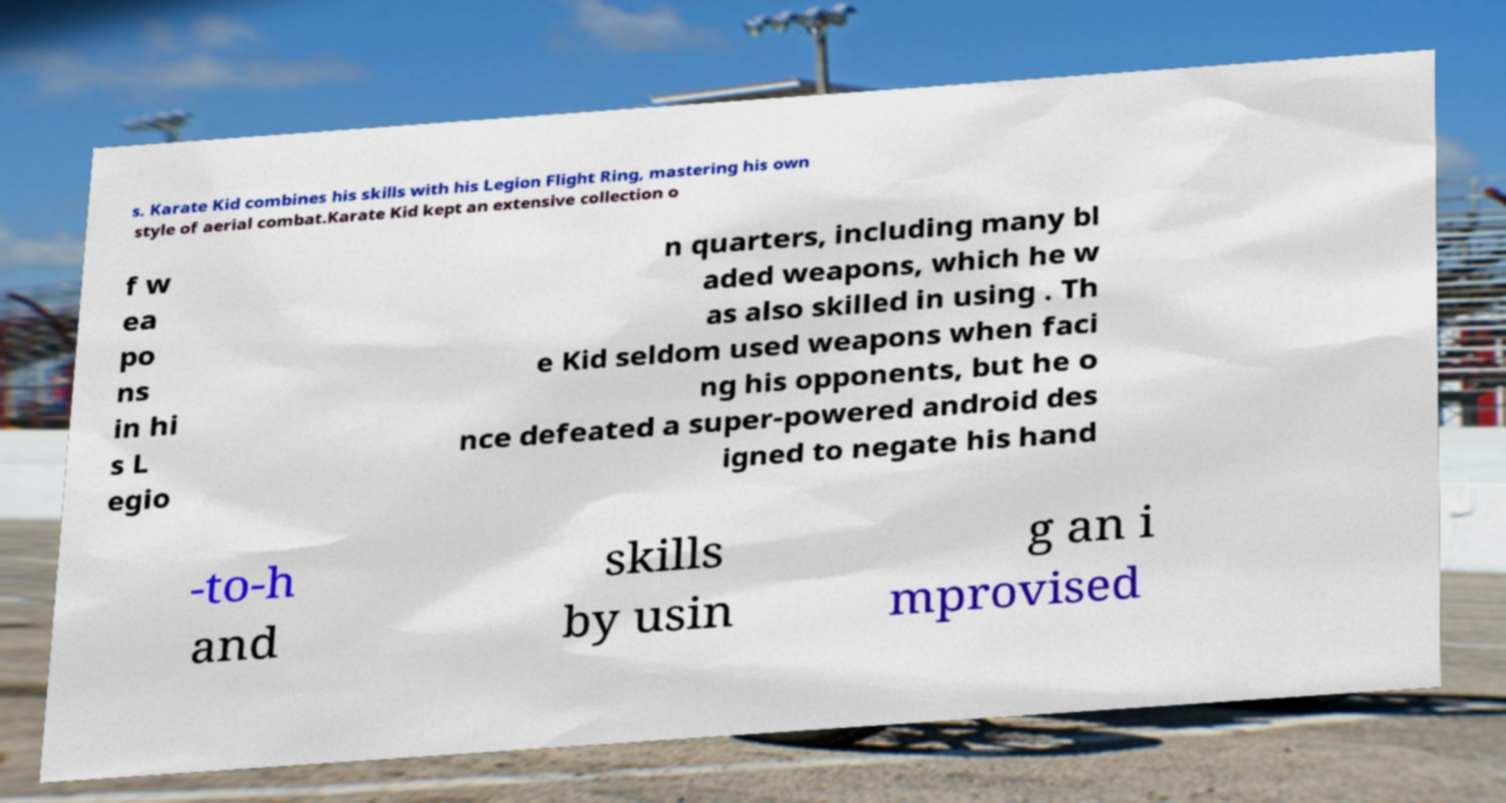For documentation purposes, I need the text within this image transcribed. Could you provide that? s. Karate Kid combines his skills with his Legion Flight Ring, mastering his own style of aerial combat.Karate Kid kept an extensive collection o f w ea po ns in hi s L egio n quarters, including many bl aded weapons, which he w as also skilled in using . Th e Kid seldom used weapons when faci ng his opponents, but he o nce defeated a super-powered android des igned to negate his hand -to-h and skills by usin g an i mprovised 